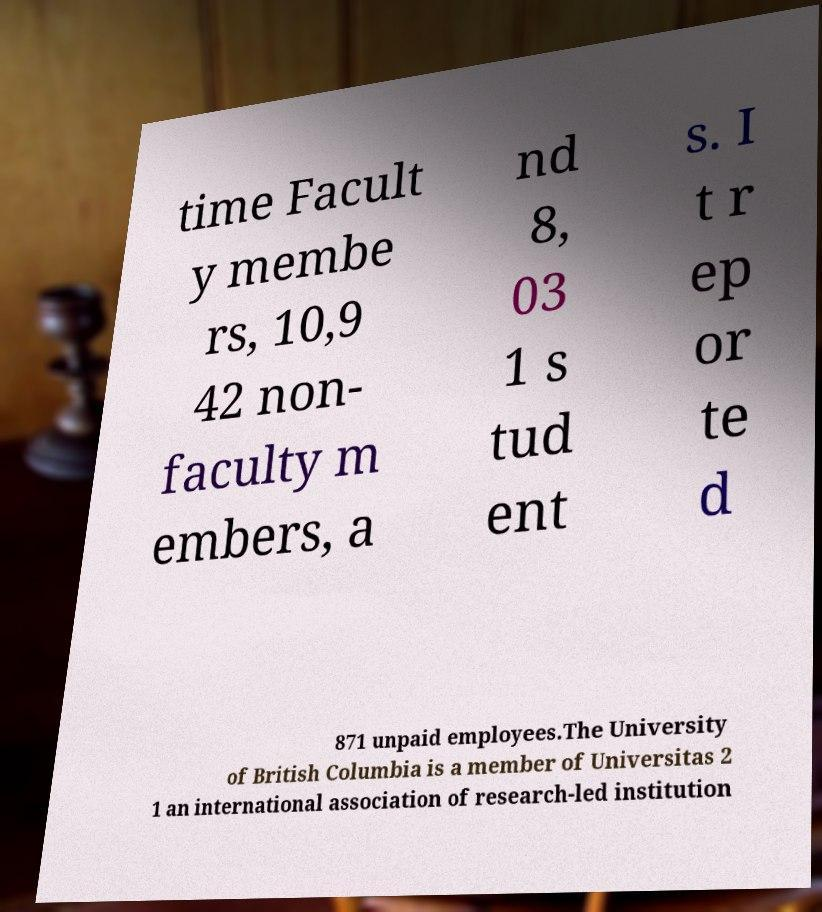For documentation purposes, I need the text within this image transcribed. Could you provide that? time Facult y membe rs, 10,9 42 non- faculty m embers, a nd 8, 03 1 s tud ent s. I t r ep or te d 871 unpaid employees.The University of British Columbia is a member of Universitas 2 1 an international association of research-led institution 